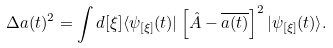<formula> <loc_0><loc_0><loc_500><loc_500>\Delta a ( t ) ^ { 2 } = \int d [ \xi ] \langle \psi _ { [ \xi ] } ( t ) | \left [ \hat { A } - \overline { a ( t ) } \right ] ^ { 2 } | \psi _ { [ \xi ] } ( t ) \rangle .</formula> 